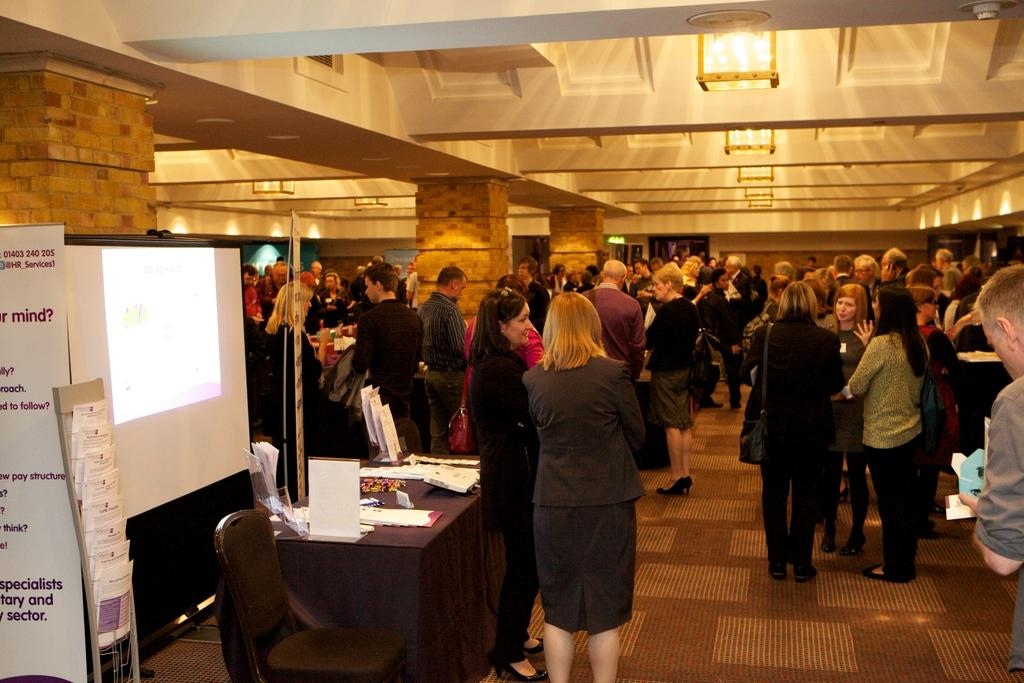How many people are in the image? There is a group of people standing in the image, but the exact number cannot be determined from the provided facts. What type of furniture is present in the image? There is a table and a chair in the image. What is covering the table in the image? There is a cloth in the image. What type of decorations are present in the image? There are posters in the image. What type of electronic device is present in the image? There is a screen in the image. What type of written material is present in the image? There are papers in the image. What type of architectural feature is present in the image? There are pillars in the image. What type of lighting is present in the image? There are lights in the image. What type of ceiling is present in the image? There is a ceiling in the image. How many thumbs can be seen on the people in the image? The number of thumbs cannot be determined from the image, as the facts do not mention the number of people or their body parts. What type of range is visible in the image? There is no range present in the image, as the facts mention only the objects and subjects listed. 